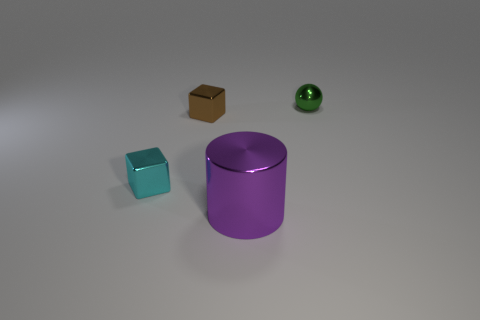Can you describe the materials of the objects present? Certainly! In the image, we observe objects that appear to be made of different materials: the tiny cyan cube and the large cylinder look metallic, with reflective surfaces, whereas the smaller brown cube seems to have a matte finish, perhaps resembling cardboard or wood, and the small sphere has a glass-like, transparent quality with a notable shine and reflection. 